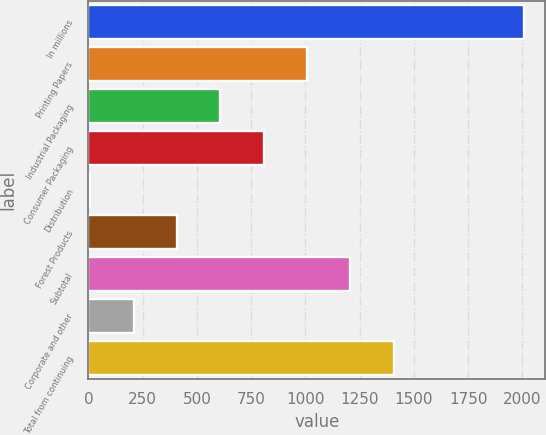<chart> <loc_0><loc_0><loc_500><loc_500><bar_chart><fcel>In millions<fcel>Printing Papers<fcel>Industrial Packaging<fcel>Consumer Packaging<fcel>Distribution<fcel>Forest Products<fcel>Subtotal<fcel>Corporate and other<fcel>Total from continuing<nl><fcel>2005<fcel>1007<fcel>607.8<fcel>807.4<fcel>9<fcel>408.2<fcel>1206.6<fcel>208.6<fcel>1406.2<nl></chart> 